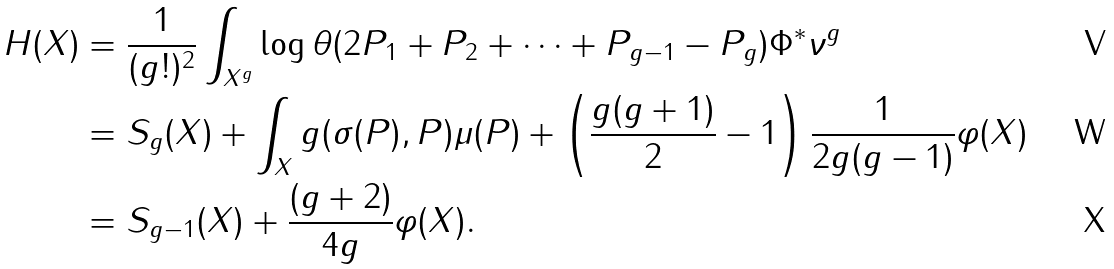<formula> <loc_0><loc_0><loc_500><loc_500>H ( X ) & = \frac { 1 } { ( g ! ) ^ { 2 } } \int _ { X ^ { g } } \log \| \theta \| ( 2 P _ { 1 } + P _ { 2 } + \dots + P _ { g - 1 } - P _ { g } ) \Phi ^ { * } \nu ^ { g } \\ & = S _ { g } ( X ) + \int _ { X } g ( \sigma ( P ) , P ) \mu ( P ) + \left ( \frac { g ( g + 1 ) } { 2 } - 1 \right ) \frac { 1 } { 2 g ( g - 1 ) } \varphi ( X ) \\ & = S _ { g - 1 } ( X ) + \frac { ( g + 2 ) } { 4 g } \varphi ( X ) .</formula> 